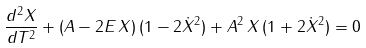Convert formula to latex. <formula><loc_0><loc_0><loc_500><loc_500>\frac { d ^ { 2 } X } { d T ^ { 2 } } + ( A - 2 E \, X ) \, ( 1 - 2 \dot { X } ^ { 2 } ) + A ^ { 2 } \, X \, ( 1 + 2 \dot { X } ^ { 2 } ) = 0 \,</formula> 